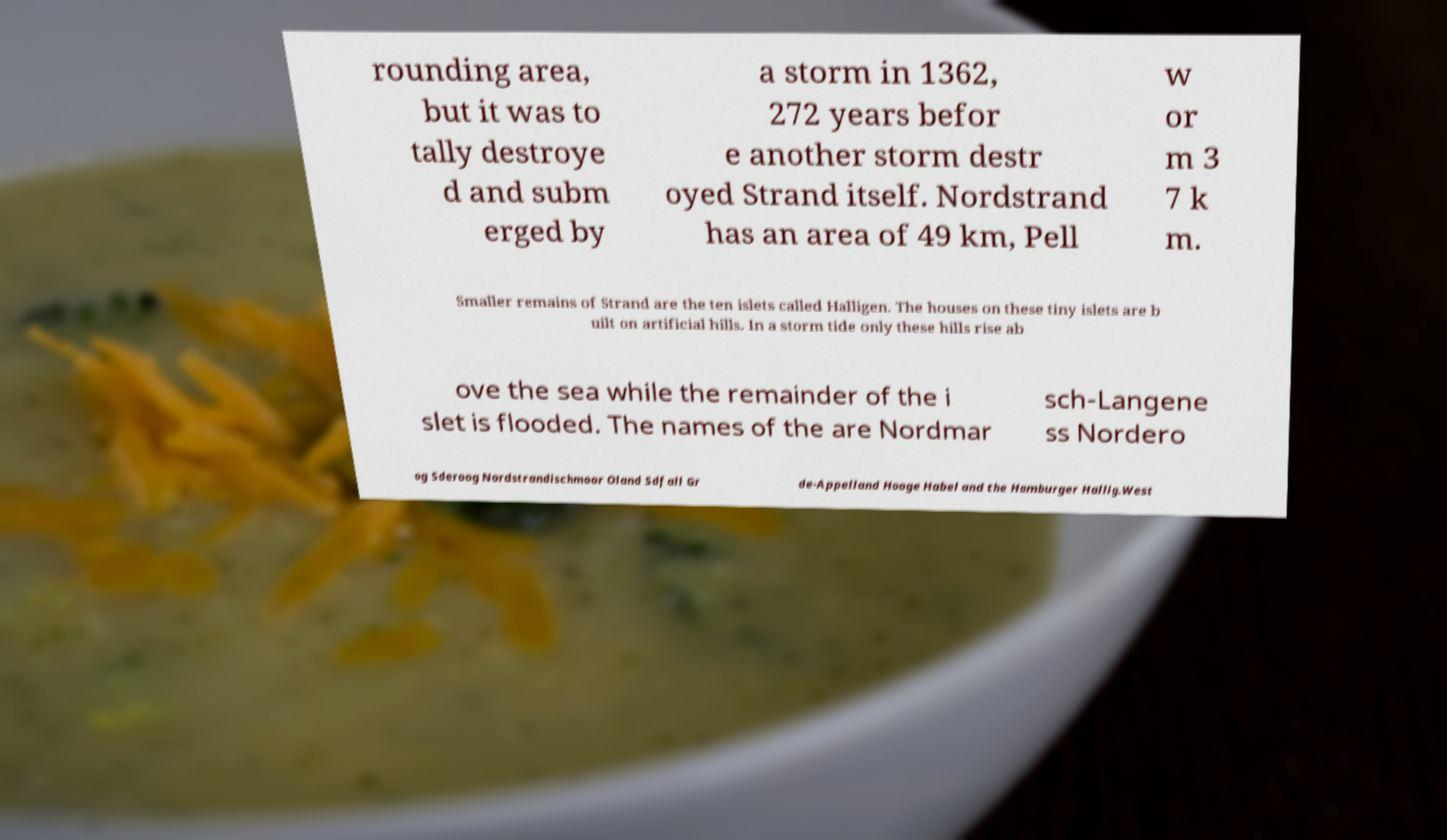What messages or text are displayed in this image? I need them in a readable, typed format. rounding area, but it was to tally destroye d and subm erged by a storm in 1362, 272 years befor e another storm destr oyed Strand itself. Nordstrand has an area of 49 km, Pell w or m 3 7 k m. Smaller remains of Strand are the ten islets called Halligen. The houses on these tiny islets are b uilt on artificial hills. In a storm tide only these hills rise ab ove the sea while the remainder of the i slet is flooded. The names of the are Nordmar sch-Langene ss Nordero og Sderoog Nordstrandischmoor Oland Sdfall Gr de-Appelland Hooge Habel and the Hamburger Hallig.West 